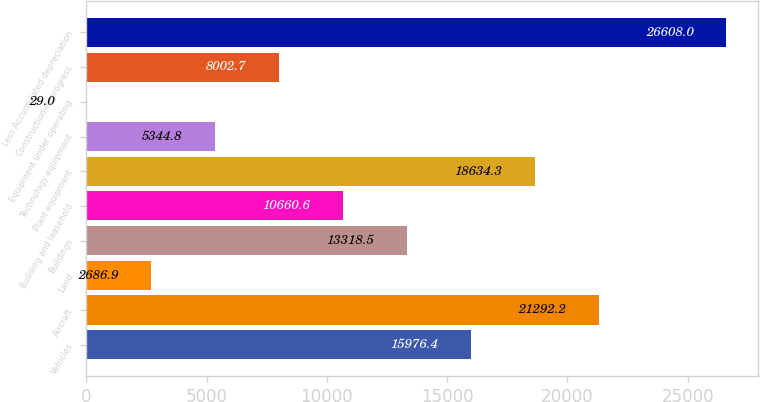Convert chart. <chart><loc_0><loc_0><loc_500><loc_500><bar_chart><fcel>Vehicles<fcel>Aircraft<fcel>Land<fcel>Buildings<fcel>Building and leasehold<fcel>Plant equipment<fcel>Technology equipment<fcel>Equipment under operating<fcel>Construction-in-progress<fcel>Less Accumulated depreciation<nl><fcel>15976.4<fcel>21292.2<fcel>2686.9<fcel>13318.5<fcel>10660.6<fcel>18634.3<fcel>5344.8<fcel>29<fcel>8002.7<fcel>26608<nl></chart> 